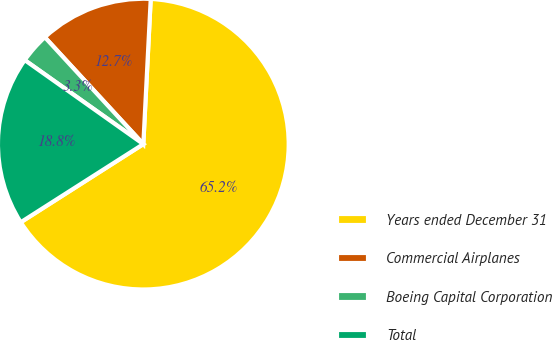Convert chart. <chart><loc_0><loc_0><loc_500><loc_500><pie_chart><fcel>Years ended December 31<fcel>Commercial Airplanes<fcel>Boeing Capital Corporation<fcel>Total<nl><fcel>65.15%<fcel>12.66%<fcel>3.34%<fcel>18.84%<nl></chart> 